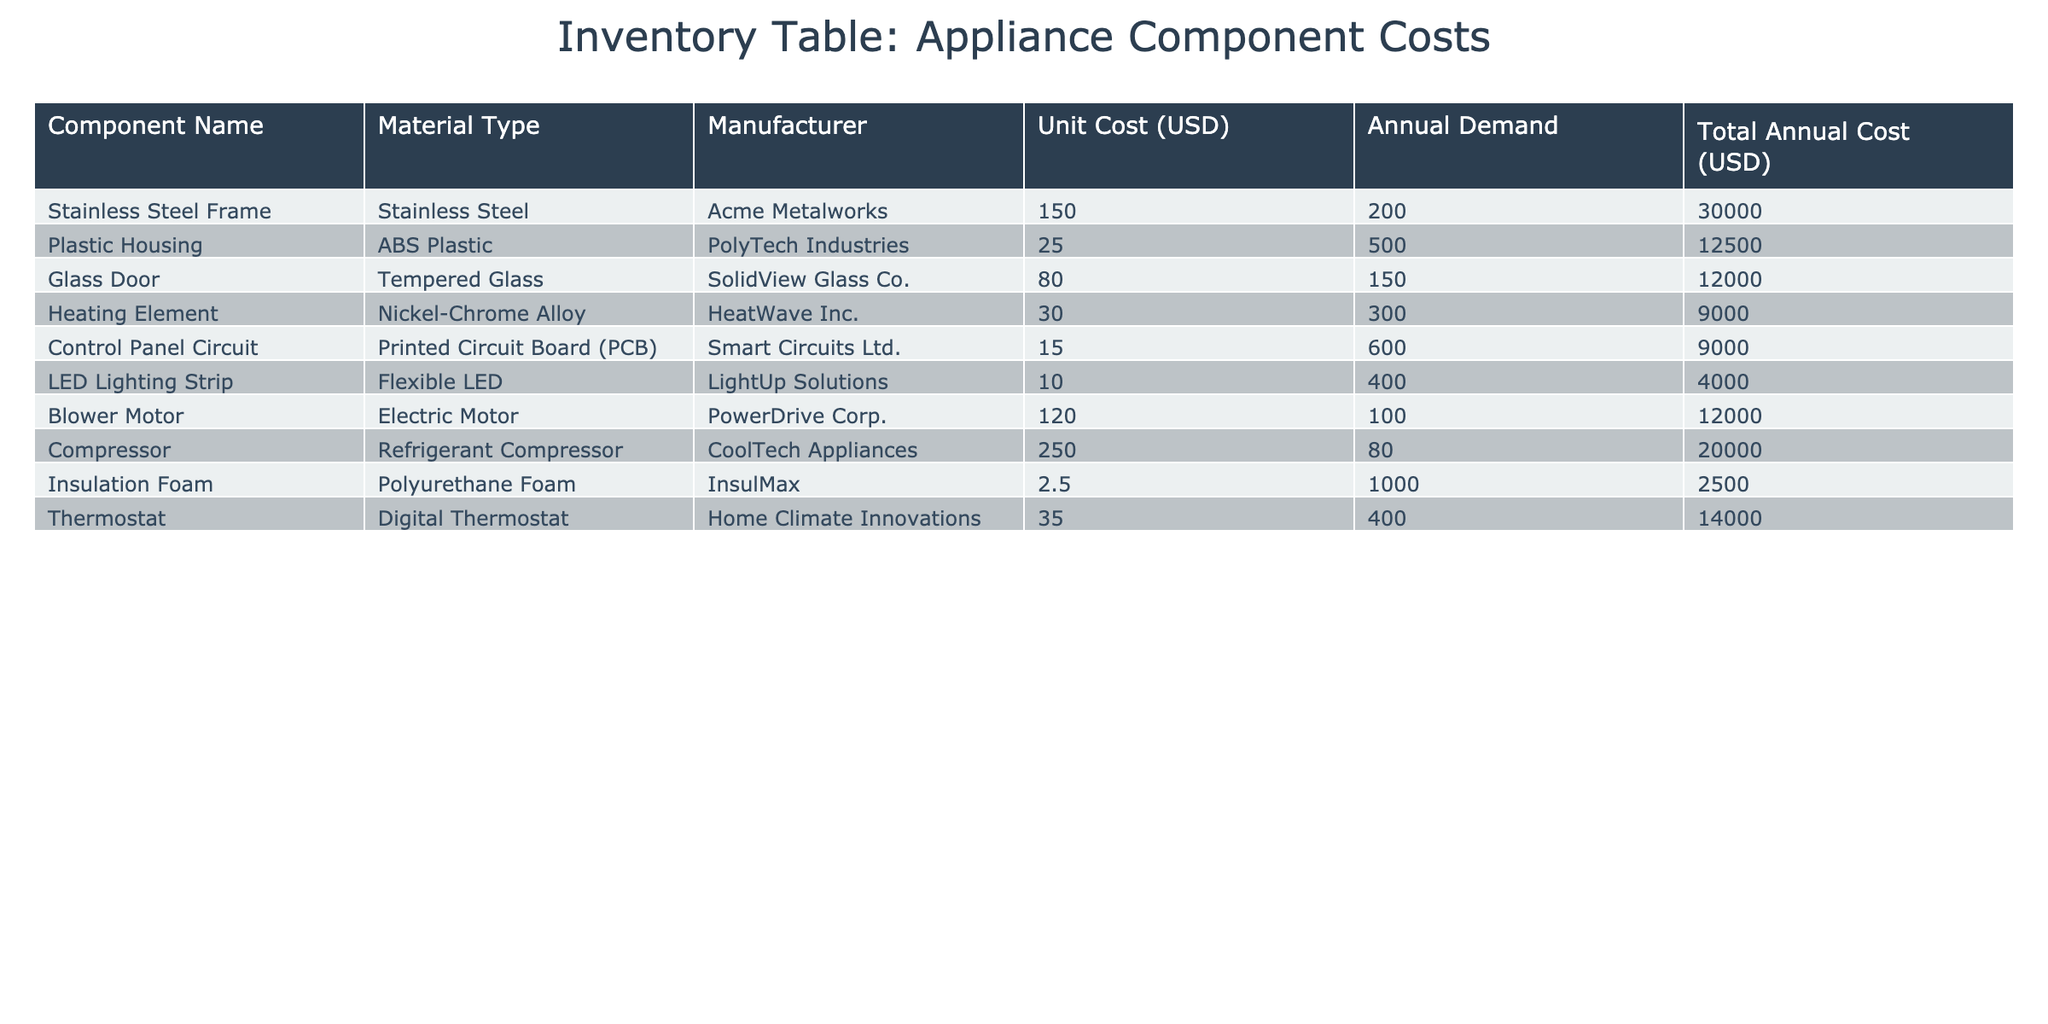What is the unit cost of the Plastic Housing? The unit cost can be found in the table under the 'Unit Cost (USD)' column corresponding to the row for 'Plastic Housing'. That value is 25.00.
Answer: 25.00 Which component has the highest total annual cost? To find this, we can look at the 'Total Annual Cost (USD)' column and identify the highest value. The 'Stainless Steel Frame' has the highest total annual cost at 30,000.00.
Answer: Stainless Steel Frame What is the total annual cost of using Insulation Foam and Control Panel Circuit combined? First, we locate each component in the table. The total annual cost for Insulation Foam is 2,500.00 and for Control Panel Circuit is 9,000.00. Adding these together (2,500.00 + 9,000.00) gives us 11,500.00.
Answer: 11,500.00 Does the Glass Door cost less than the Heating Element? Comparing the 'Unit Cost (USD)' of both components, the Glass Door costs 80.00 while the Heating Element costs 30.00. Since 80.00 is greater than 30.00, the statement is false.
Answer: No Which material type has the lowest average unit cost among the components listed? First, we categorize the unit costs by material type. The unit costs are as follows: Stainless Steel 150.00, ABS Plastic 25.00, Tempered Glass 80.00, Nickel-Chrome Alloy 30.00, PCB 15.00, Flexible LED 10.00, Electric Motor 120.00, Refrigerant Compressor 250.00, Polyurethane Foam 2.50, Digital Thermostat 35.00. The average for Polyurethane Foam is the lowest at 2.50.
Answer: Polyurethane Foam What is the difference in total annual cost between the Blower Motor and the Compressor? The total annual cost of the Blower Motor is 12,000.00 and for the Compressor, it's 20,000.00. The difference is calculated by subtracting the Blower Motor cost from the Compressor cost (20,000.00 - 12,000.00), which equals 8,000.00.
Answer: 8,000.00 Is the annual demand for the LED Lighting Strip greater than that for the Thermostat? Looking at the 'Annual Demand' column, the LED Lighting Strip has a demand of 400, while the Thermostat has a demand of 400 too. Since they are equal, the statement is false.
Answer: No What would be the total annual cost if the annual demand for the Heating Element doubled? The current annual demand for the Heating Element is 300. The new demand would be 600 (300 * 2). The unit cost is 30.00, so the total annual cost would be calculated as 600 * 30.00 = 18,000.00.
Answer: 18,000.00 Which component's manufacturer is PowerDrive Corp.? Referring to the 'Manufacturer' column, the component associated with PowerDrive Corp. is the Blower Motor.
Answer: Blower Motor 